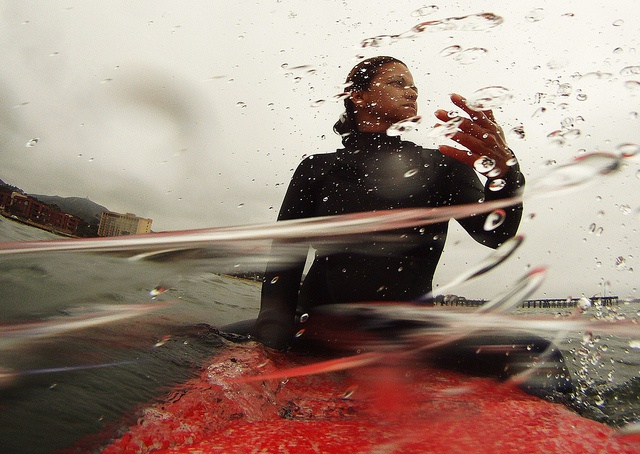Describe the objects in this image and their specific colors. I can see surfboard in beige, brown, and maroon tones and people in beige, black, maroon, gray, and ivory tones in this image. 